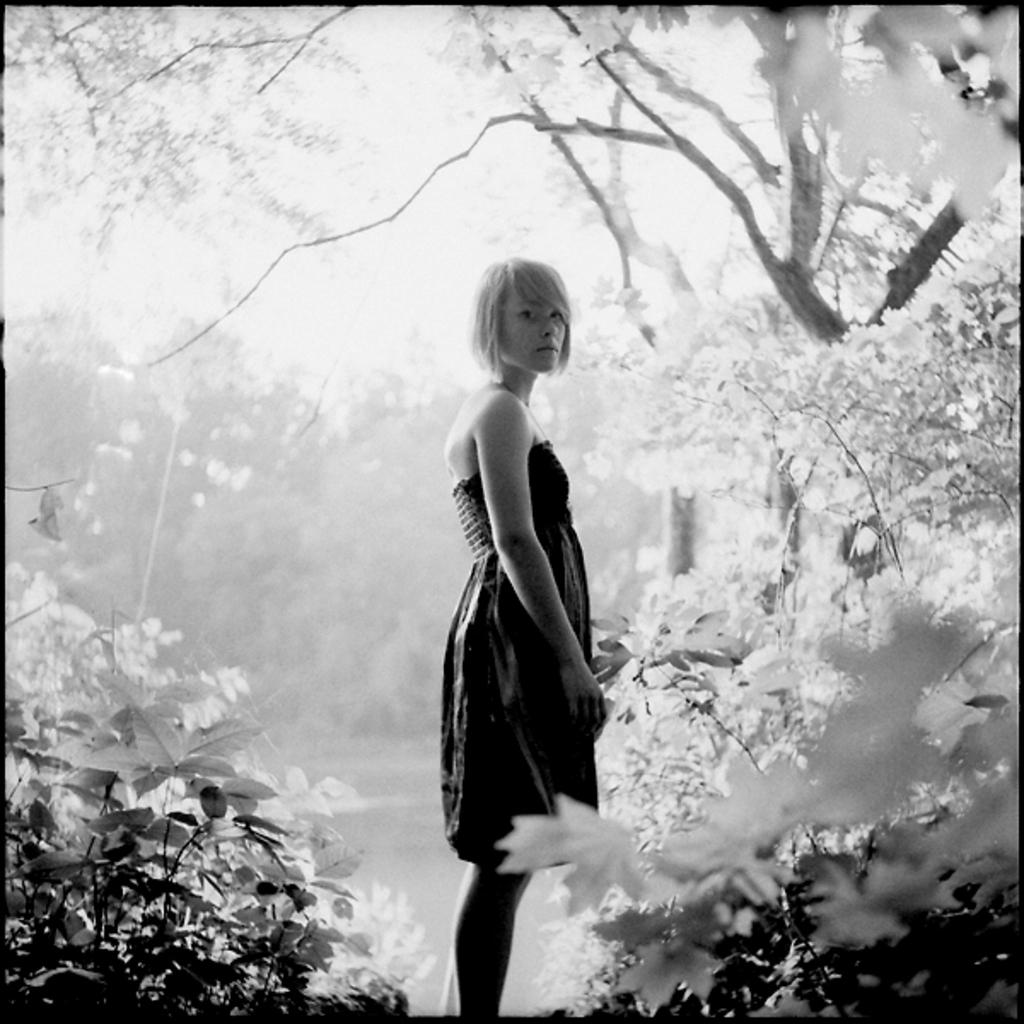What is the color scheme of the image? The image is black and white. What can be seen in the image besides the color scheme? There is a woman standing in the image, as well as plants and trees. What invention is being demonstrated by the woman in the image? There is no invention being demonstrated by the woman in the image; she is simply standing in the image. 